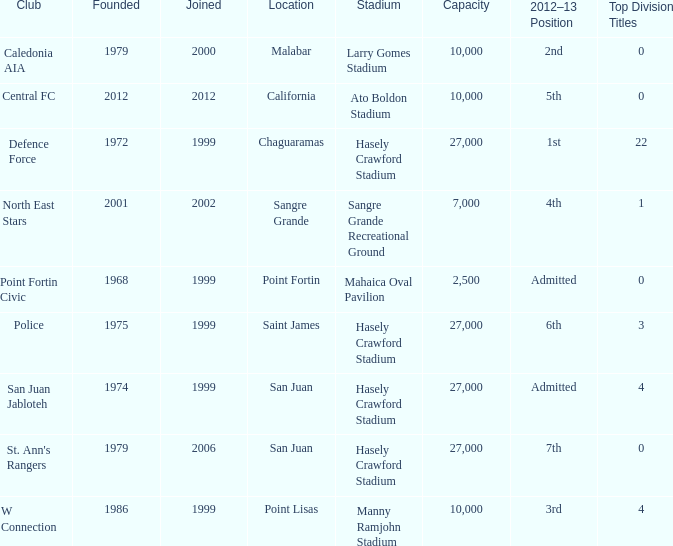Which stadium was used for the North East Stars club? Sangre Grande Recreational Ground. Could you parse the entire table? {'header': ['Club', 'Founded', 'Joined', 'Location', 'Stadium', 'Capacity', '2012–13 Position', 'Top Division Titles'], 'rows': [['Caledonia AIA', '1979', '2000', 'Malabar', 'Larry Gomes Stadium', '10,000', '2nd', '0'], ['Central FC', '2012', '2012', 'California', 'Ato Boldon Stadium', '10,000', '5th', '0'], ['Defence Force', '1972', '1999', 'Chaguaramas', 'Hasely Crawford Stadium', '27,000', '1st', '22'], ['North East Stars', '2001', '2002', 'Sangre Grande', 'Sangre Grande Recreational Ground', '7,000', '4th', '1'], ['Point Fortin Civic', '1968', '1999', 'Point Fortin', 'Mahaica Oval Pavilion', '2,500', 'Admitted', '0'], ['Police', '1975', '1999', 'Saint James', 'Hasely Crawford Stadium', '27,000', '6th', '3'], ['San Juan Jabloteh', '1974', '1999', 'San Juan', 'Hasely Crawford Stadium', '27,000', 'Admitted', '4'], ["St. Ann's Rangers", '1979', '2006', 'San Juan', 'Hasely Crawford Stadium', '27,000', '7th', '0'], ['W Connection', '1986', '1999', 'Point Lisas', 'Manny Ramjohn Stadium', '10,000', '3rd', '4']]} 